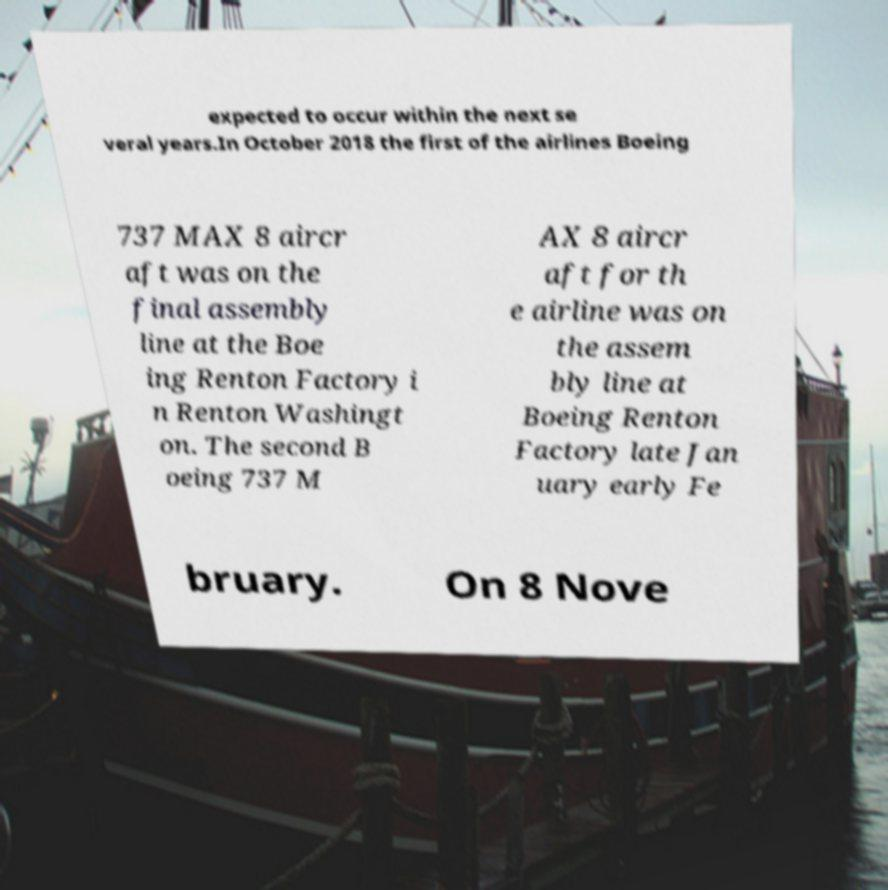Could you extract and type out the text from this image? expected to occur within the next se veral years.In October 2018 the first of the airlines Boeing 737 MAX 8 aircr aft was on the final assembly line at the Boe ing Renton Factory i n Renton Washingt on. The second B oeing 737 M AX 8 aircr aft for th e airline was on the assem bly line at Boeing Renton Factory late Jan uary early Fe bruary. On 8 Nove 